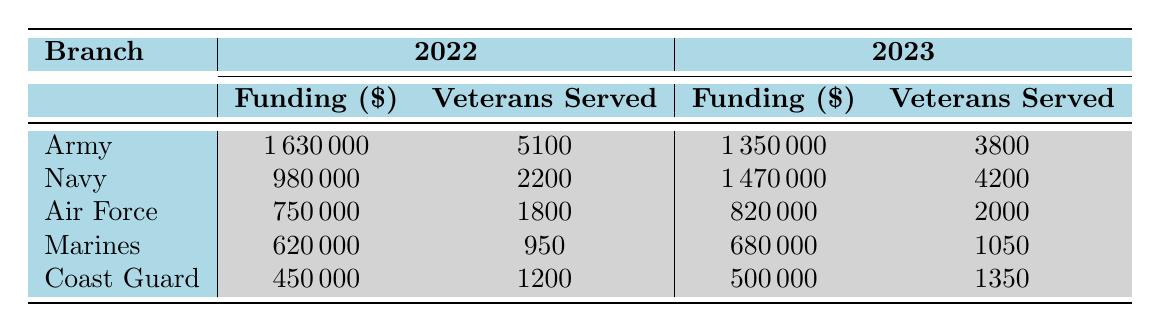What is the total funding allocated for the Army in 2022? The funding for the Army in 2022 is listed as 1,630,000 in the table.
Answer: 1,630,000 How many veterans were served by the Navy in 2023? The number of veterans served by the Navy in 2023 is provided in the table as 4,200.
Answer: 4,200 Is there a difference in the funding allocated to the Marines between 2022 and 2023? The funding for the Marines in 2022 is 620,000, and in 2023 it is 680,000. The difference is 680,000 - 620,000 = 60,000.
Answer: Yes, the difference is 60,000 What is the average number of veterans served across all branches in 2022? The total number of veterans served in 2022 is 5,100 (Army) + 2,200 (Navy) + 1,800 (Air Force) + 950 (Marines) + 1,200 (Coast Guard) = 11,250. There are 5 branches, so the average is 11,250 / 5 = 2,250.
Answer: 2,250 Did the funding amount for the Air Force increase from 2022 to 2023? The funding for the Air Force in 2022 is 750,000 and in 2023 is 820,000. Since 820,000 is greater than 750,000, it did increase.
Answer: Yes What percentage of the total funding in 2023 was allocated to the Navy? The total funding for 2023 is 1,350,000 (Army) + 1,470,000 (Navy) + 820,000 (Air Force) + 680,000 (Marines) + 500,000 (Coast Guard) = 4,820,000. The funding for the Navy is 1,470,000. The percentage is (1,470,000 / 4,820,000) * 100 = 30.53%.
Answer: 30.53% Which branch served the highest number of veterans in 2022? The table shows the number of veterans served by each branch in 2022: Army (5,100), Navy (2,200), Air Force (1,800), Marines (950), Coast Guard (1,200). The Army served the highest number.
Answer: Army Was the funding for housing assistance lower than for job training in the Marines in 2023? The funding for housing assistance in 2023 for the Marines is 680,000, while the Air Force received 820,000 for job training. Since 680,000 is less than 820,000, the answer is yes.
Answer: Yes 